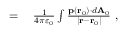Convert formula to latex. <formula><loc_0><loc_0><loc_500><loc_500>\begin{array} { r l } { } & { \frac { 1 } { 4 \pi \varepsilon _ { 0 } } } \int { \frac { p \left ( r _ { 0 } \right ) \cdot d A _ { 0 } } { \left | r - r _ { 0 } \right | } } \ , } \end{array}</formula> 